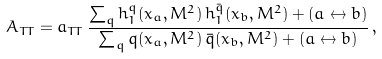Convert formula to latex. <formula><loc_0><loc_0><loc_500><loc_500>A _ { T T } = a _ { T T } \, \frac { \sum _ { q } h _ { 1 } ^ { q } ( x _ { a } , M ^ { 2 } ) \, h _ { 1 } ^ { \bar { q } } ( x _ { b } , M ^ { 2 } ) + ( a \leftrightarrow b ) } { \sum _ { q } q ( x _ { a } , M ^ { 2 } ) \, \bar { q } ( x _ { b } , M ^ { 2 } ) + ( a \leftrightarrow b ) } \, ,</formula> 